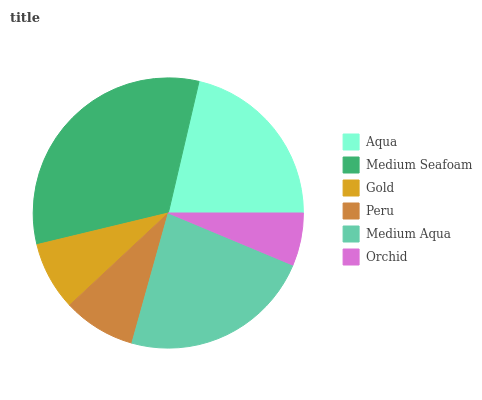Is Orchid the minimum?
Answer yes or no. Yes. Is Medium Seafoam the maximum?
Answer yes or no. Yes. Is Gold the minimum?
Answer yes or no. No. Is Gold the maximum?
Answer yes or no. No. Is Medium Seafoam greater than Gold?
Answer yes or no. Yes. Is Gold less than Medium Seafoam?
Answer yes or no. Yes. Is Gold greater than Medium Seafoam?
Answer yes or no. No. Is Medium Seafoam less than Gold?
Answer yes or no. No. Is Aqua the high median?
Answer yes or no. Yes. Is Peru the low median?
Answer yes or no. Yes. Is Peru the high median?
Answer yes or no. No. Is Orchid the low median?
Answer yes or no. No. 